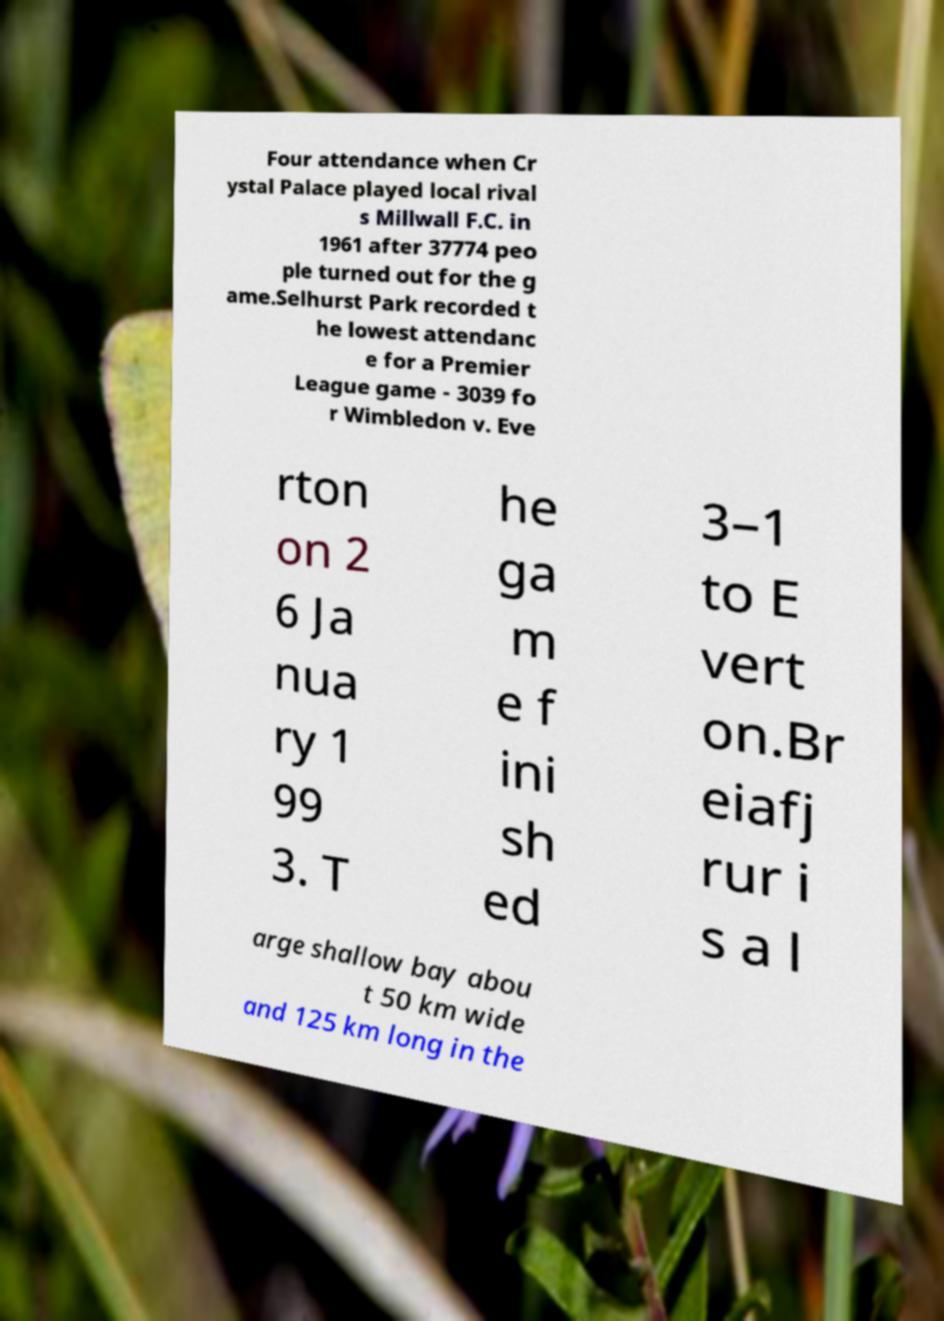Can you read and provide the text displayed in the image?This photo seems to have some interesting text. Can you extract and type it out for me? Four attendance when Cr ystal Palace played local rival s Millwall F.C. in 1961 after 37774 peo ple turned out for the g ame.Selhurst Park recorded t he lowest attendanc e for a Premier League game - 3039 fo r Wimbledon v. Eve rton on 2 6 Ja nua ry 1 99 3. T he ga m e f ini sh ed 3–1 to E vert on.Br eiafj rur i s a l arge shallow bay abou t 50 km wide and 125 km long in the 